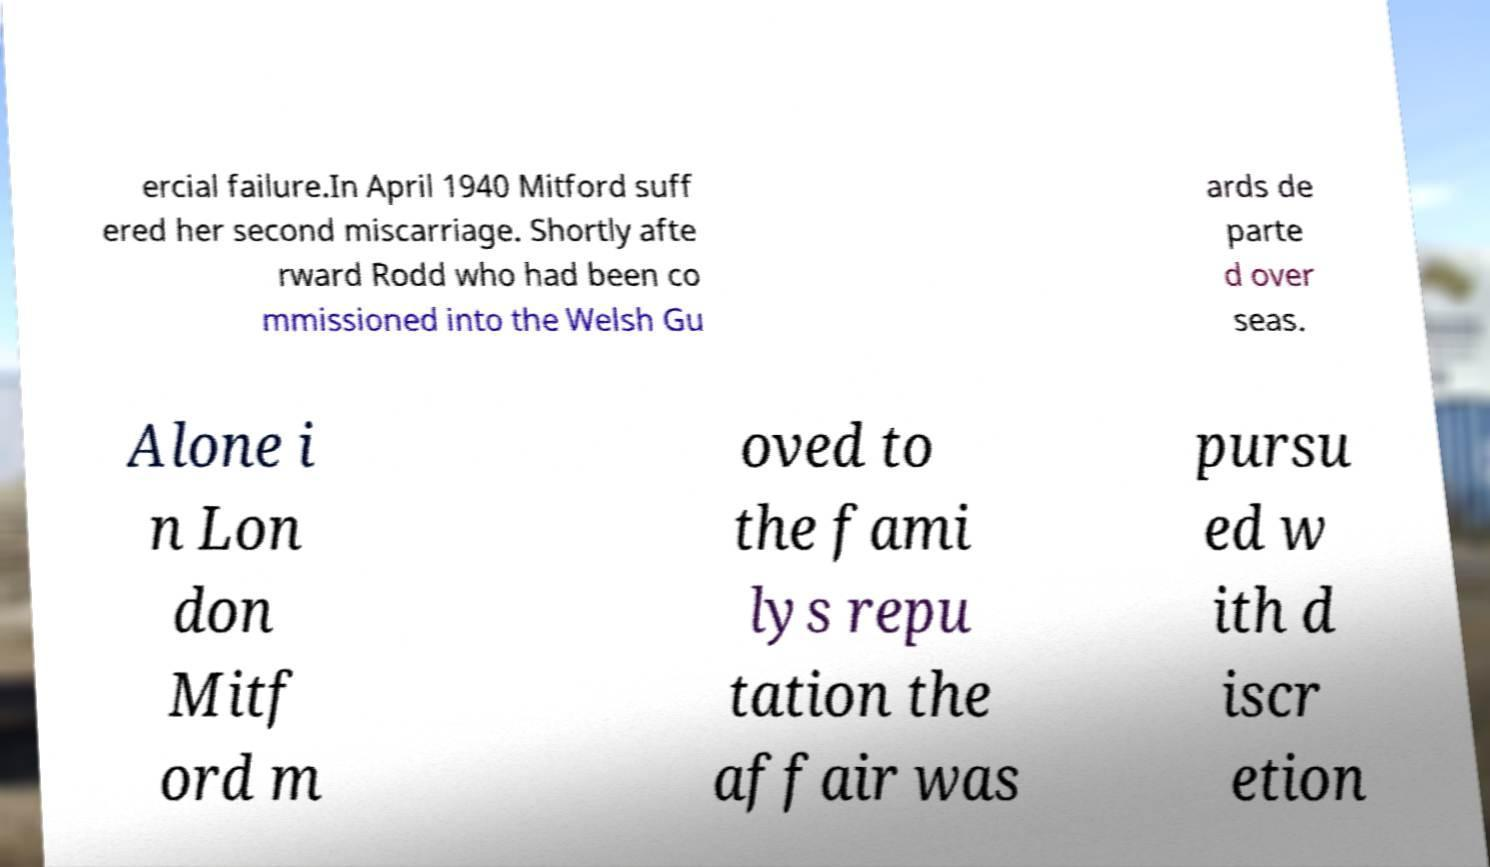Can you read and provide the text displayed in the image?This photo seems to have some interesting text. Can you extract and type it out for me? ercial failure.In April 1940 Mitford suff ered her second miscarriage. Shortly afte rward Rodd who had been co mmissioned into the Welsh Gu ards de parte d over seas. Alone i n Lon don Mitf ord m oved to the fami lys repu tation the affair was pursu ed w ith d iscr etion 